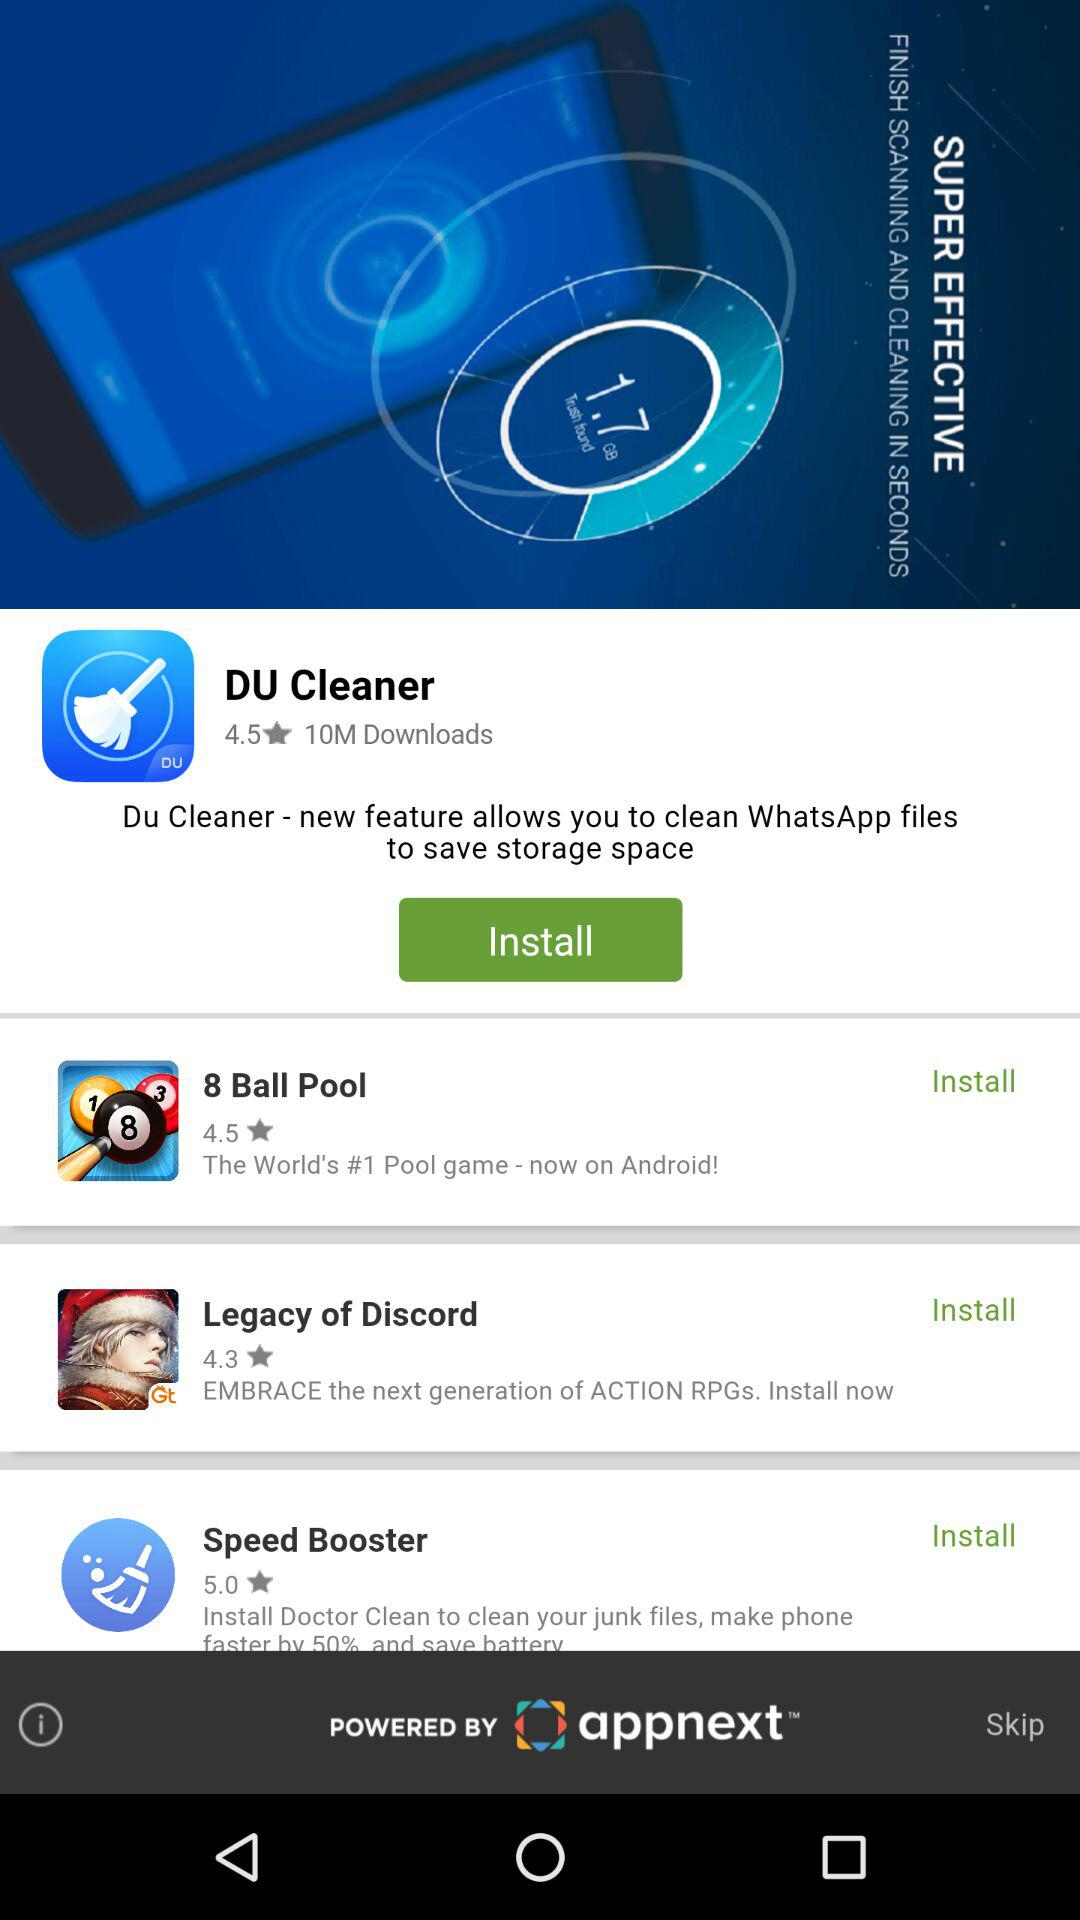What is the rating of Legacy of Discord? The rating of Legacy of Discord is 4.3 stars. 